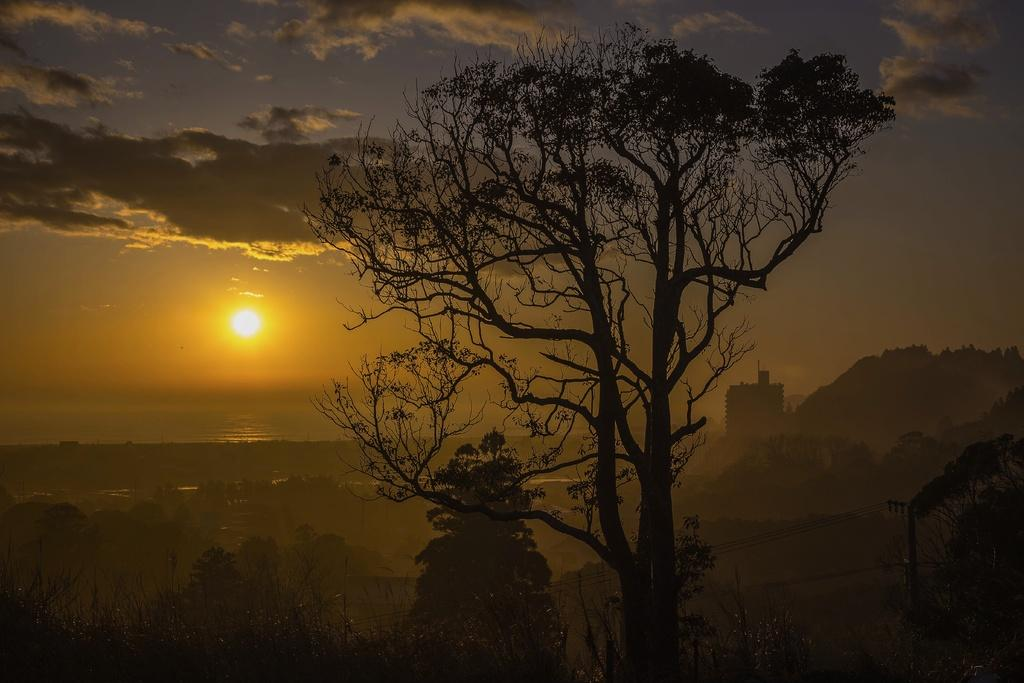What type of structure is present in the image? There is a building in the image. What other natural elements can be seen in the image? There are trees in the image. What is the purpose of the pole visible in the image? The pole in the image is a current pole. What celestial body is visible in the image? The moon is visible in the image. What part of the natural environment is visible in the image? The sky is visible in the image. What invention is being demonstrated in the image? There is no invention being demonstrated in the image; it features a building, trees, a current pole, the moon, and the sky. What month is depicted in the image? The image does not depict a specific month; it only shows the moon, which is visible in various months. 